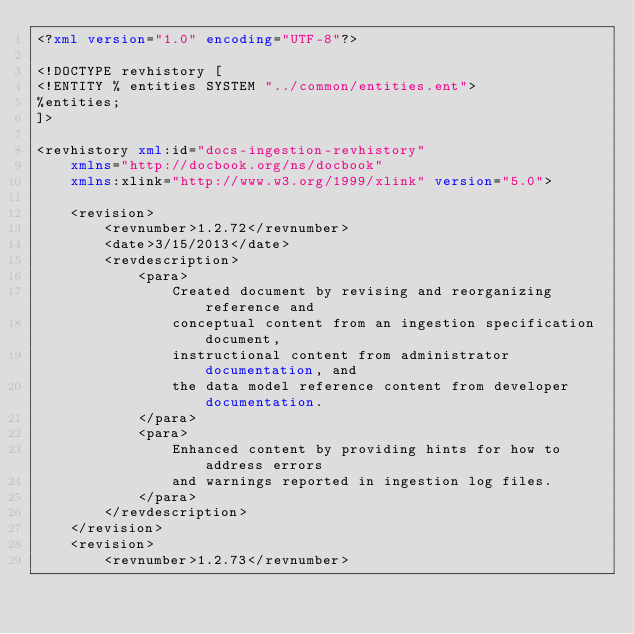<code> <loc_0><loc_0><loc_500><loc_500><_XML_><?xml version="1.0" encoding="UTF-8"?>

<!DOCTYPE revhistory [
<!ENTITY % entities SYSTEM "../common/entities.ent">
%entities;
]>

<revhistory xml:id="docs-ingestion-revhistory"
    xmlns="http://docbook.org/ns/docbook" 
    xmlns:xlink="http://www.w3.org/1999/xlink" version="5.0">
    
    <revision>
        <revnumber>1.2.72</revnumber>
        <date>3/15/2013</date>
        <revdescription>
            <para>
                Created document by revising and reorganizing reference and
                conceptual content from an ingestion specification document, 
                instructional content from administrator documentation, and
                the data model reference content from developer documentation.
            </para>
            <para>
                Enhanced content by providing hints for how to address errors
                and warnings reported in ingestion log files.
            </para>
        </revdescription>
    </revision>
    <revision>
        <revnumber>1.2.73</revnumber></code> 